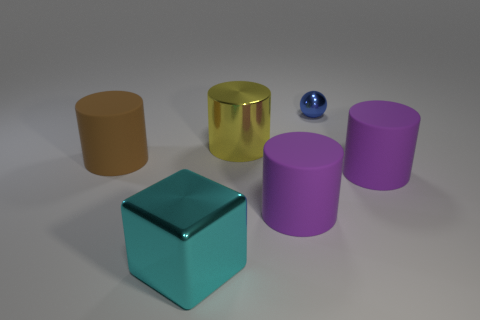The brown thing that is the same size as the yellow object is what shape?
Your answer should be very brief. Cylinder. Are there any shiny objects behind the cyan object?
Make the answer very short. Yes. Does the big cylinder left of the cyan block have the same material as the large purple thing that is left of the blue sphere?
Ensure brevity in your answer.  Yes. How many brown rubber cylinders are the same size as the blue sphere?
Give a very brief answer. 0. What is the cylinder to the left of the yellow shiny cylinder made of?
Offer a terse response. Rubber. How many big purple things have the same shape as the large yellow shiny object?
Provide a succinct answer. 2. There is a large cyan thing that is made of the same material as the yellow cylinder; what shape is it?
Make the answer very short. Cube. What is the shape of the large purple thing that is behind the purple object that is to the left of the purple object that is right of the small metallic ball?
Offer a very short reply. Cylinder. Are there more big purple rubber cylinders than big brown cylinders?
Provide a succinct answer. Yes. What is the material of the large yellow object that is the same shape as the large brown rubber thing?
Provide a succinct answer. Metal. 